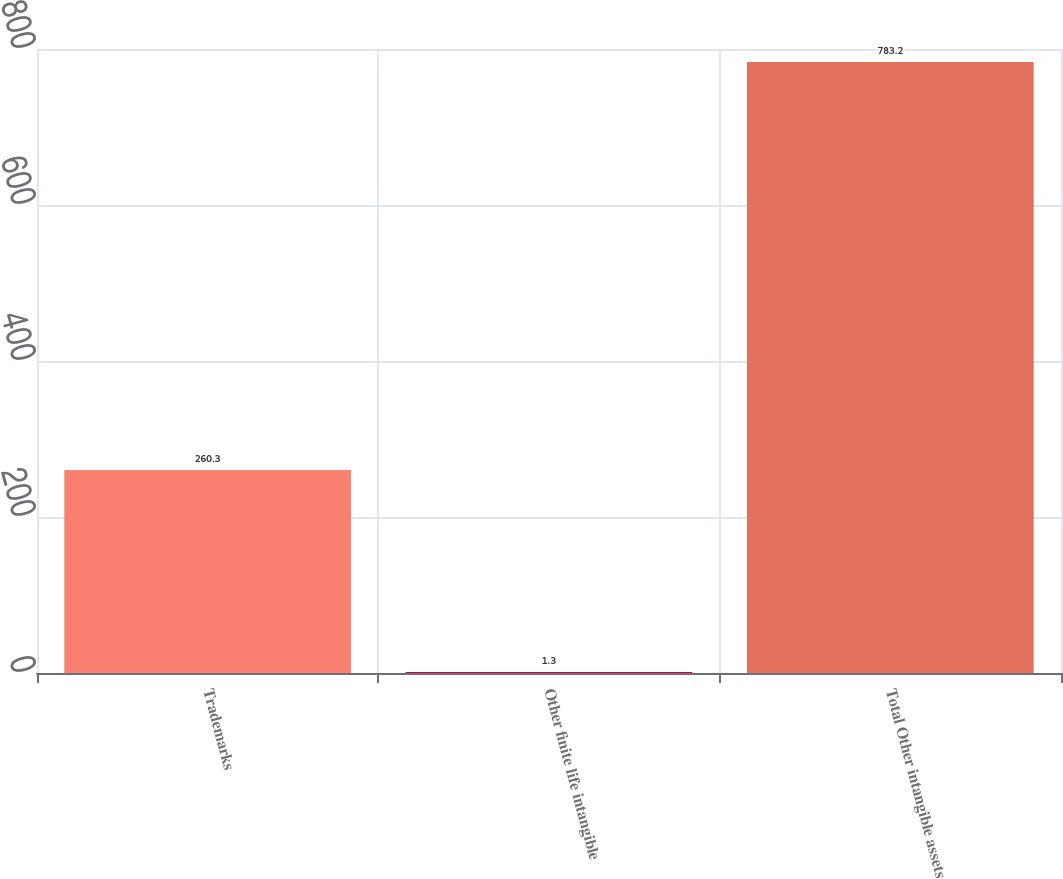<chart> <loc_0><loc_0><loc_500><loc_500><bar_chart><fcel>Trademarks<fcel>Other finite life intangible<fcel>Total Other intangible assets<nl><fcel>260.3<fcel>1.3<fcel>783.2<nl></chart> 